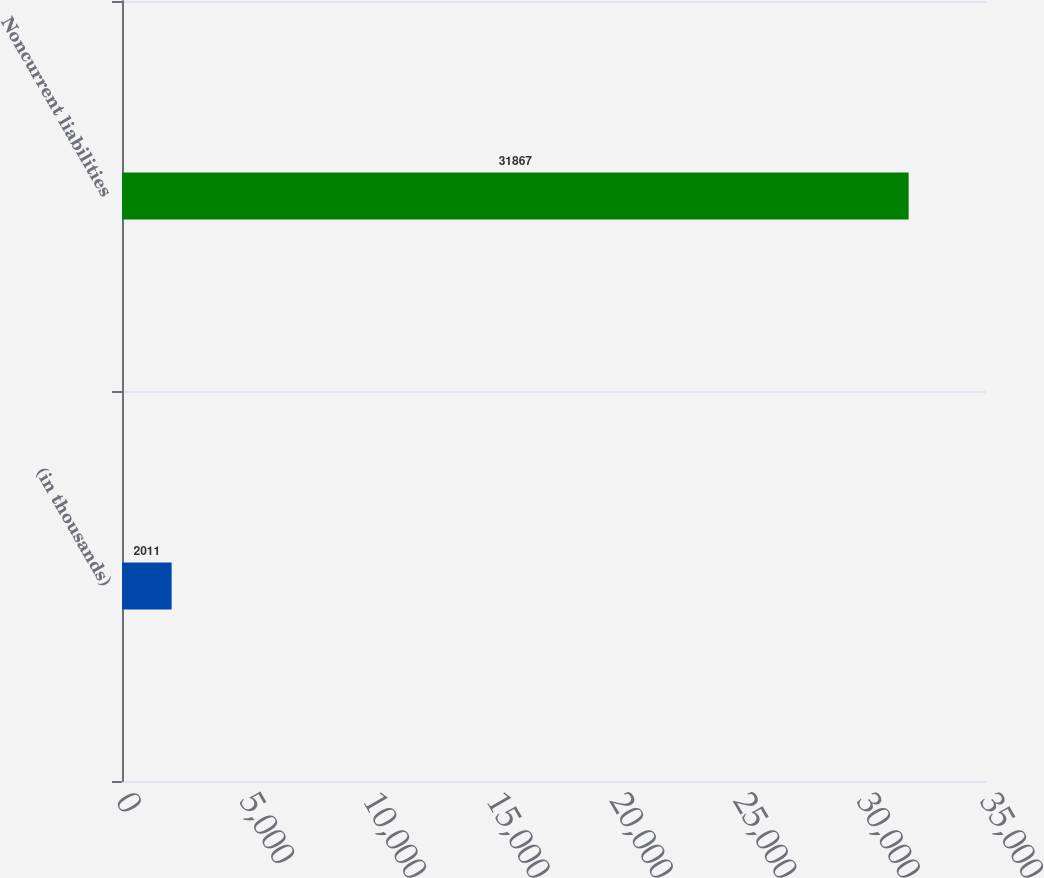<chart> <loc_0><loc_0><loc_500><loc_500><bar_chart><fcel>(in thousands)<fcel>Noncurrent liabilities<nl><fcel>2011<fcel>31867<nl></chart> 